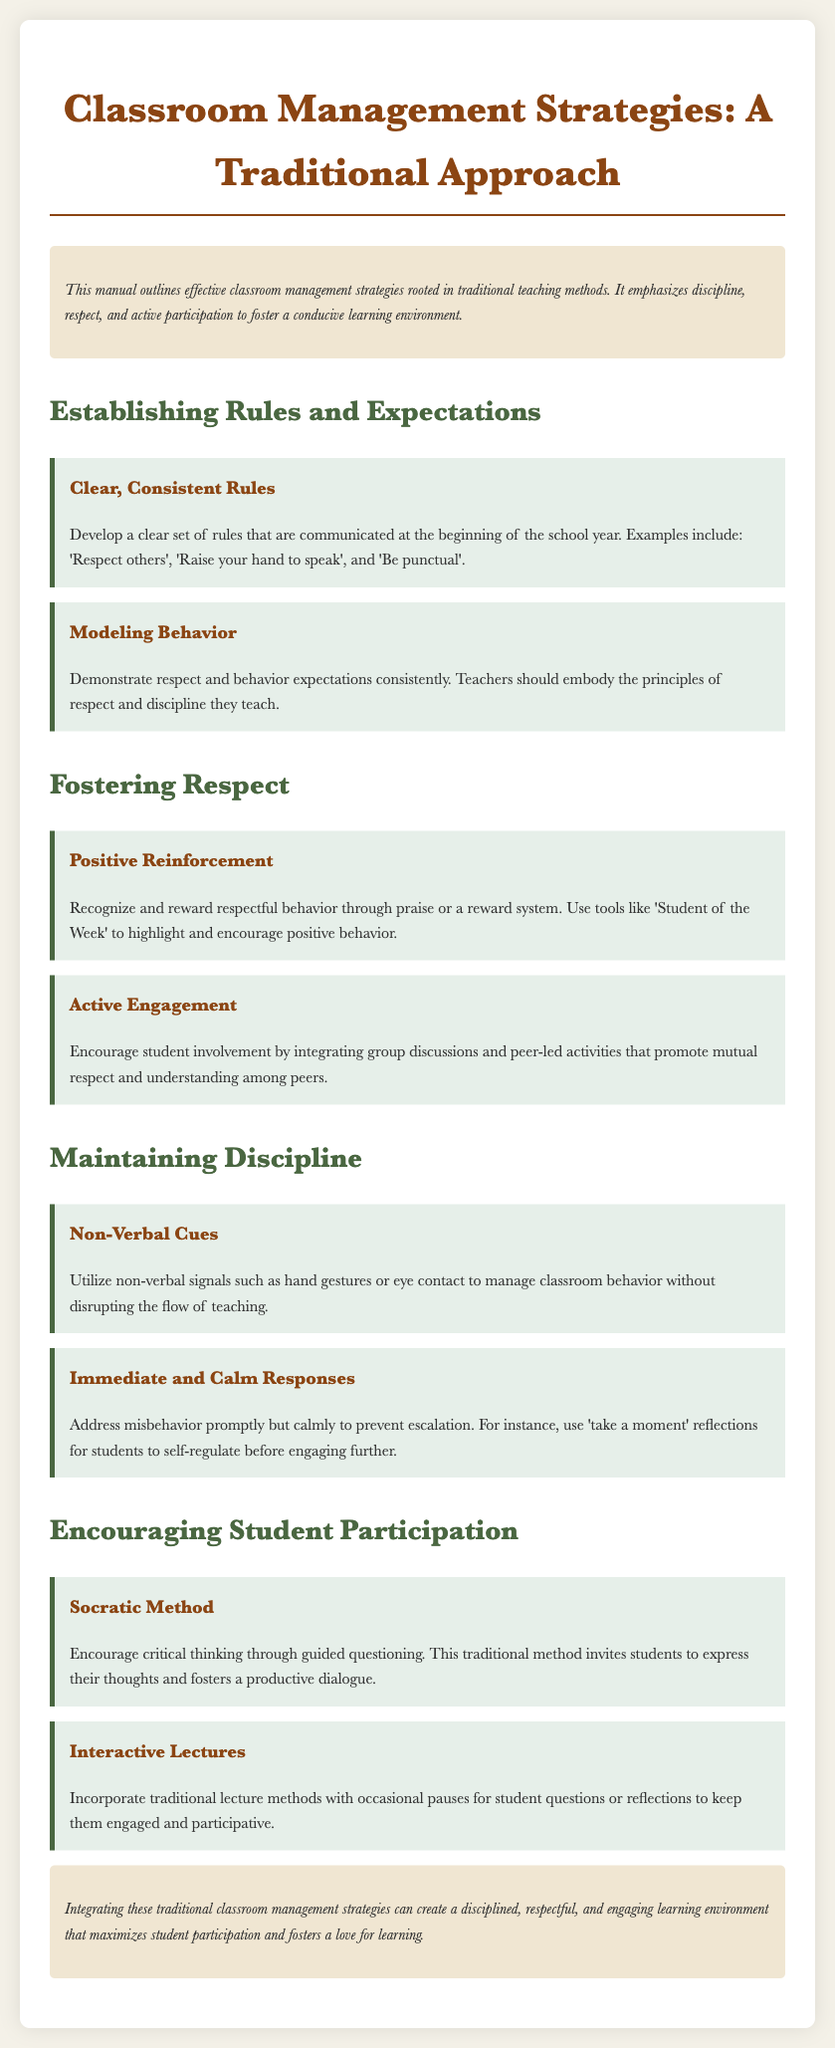What is the title of the document? The title of the document is provided at the beginning, clearly indicating the subject matter it covers.
Answer: Classroom Management Strategies: A Traditional Approach What is one of the rules suggested for students? The document lists multiple rules. An example can be found under the section establishing rules and expectations.
Answer: Respect others What strategy is used for positive reinforcement? The document mentions various strategies for fostering respect, and one includes a specific approach to recognize positive behavior.
Answer: Student of the Week What method encourages critical thinking? The document describes several methods for encouraging student participation, identifying a traditional approach that promotes deeper thinking through questioning.
Answer: Socratic Method What action should be taken to address misbehavior? The section on maintaining discipline outlines a strategy for responding to disruptive behavior in a calm and effective manner.
Answer: Immediate and Calm Responses How should teachers model behavior? The document emphasizes the importance of teachers demonstrating expected behaviors to reinforce the rules and principles taught.
Answer: Modeling Behavior What is the purpose of using non-verbal cues? The purpose of non-verbal cues is outlined in relation to managing classroom behavior without disruption, highlighting a specific strategy.
Answer: Manage classroom behavior Which technique combines traditional lectures with student engagement? The document provides a strategy under encouraging student participation that merges a traditional teaching approach with interactive engagement.
Answer: Interactive Lectures 